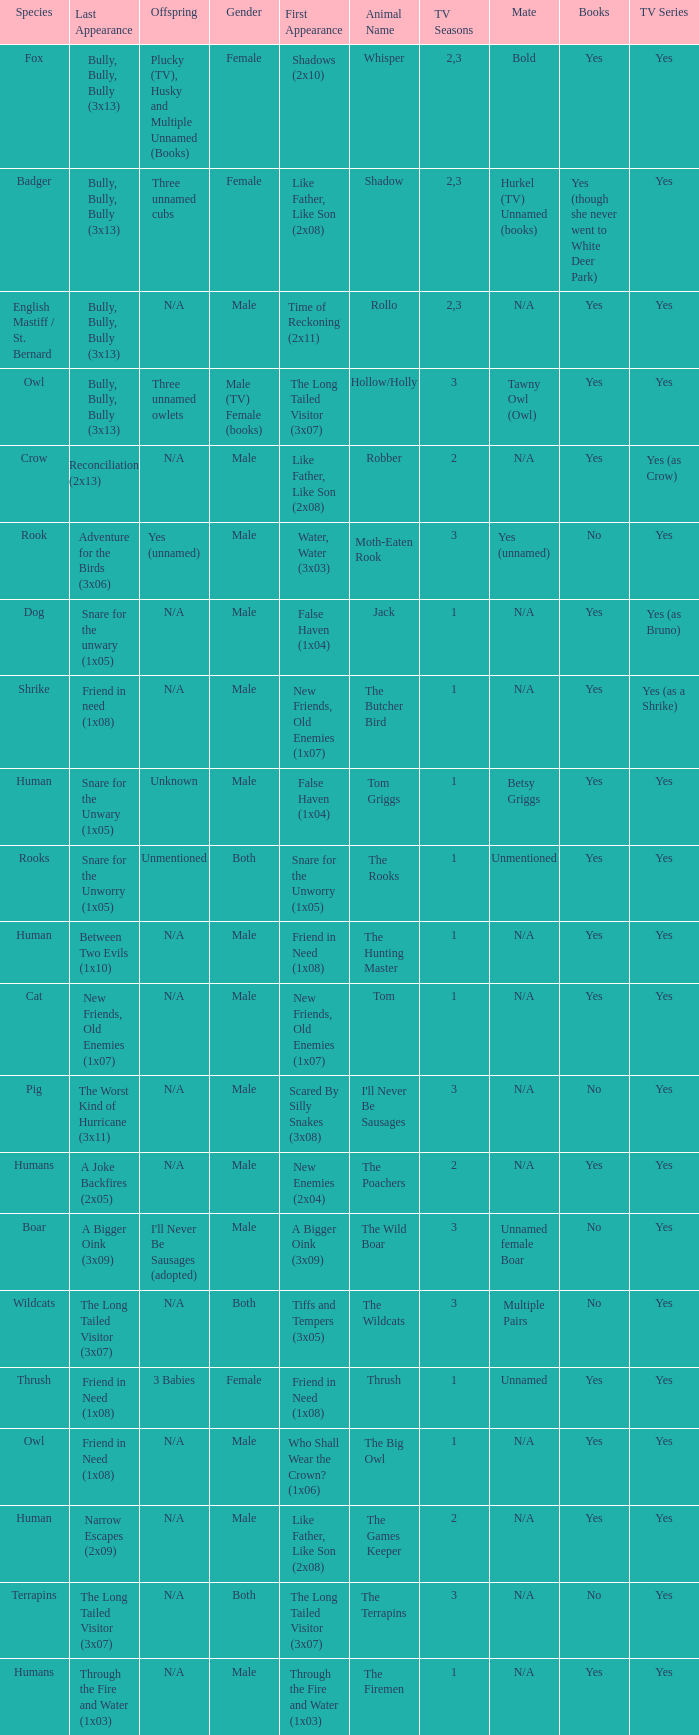What is the mate for Last Appearance of bully, bully, bully (3x13) for the animal named hollow/holly later than season 1? Tawny Owl (Owl). 